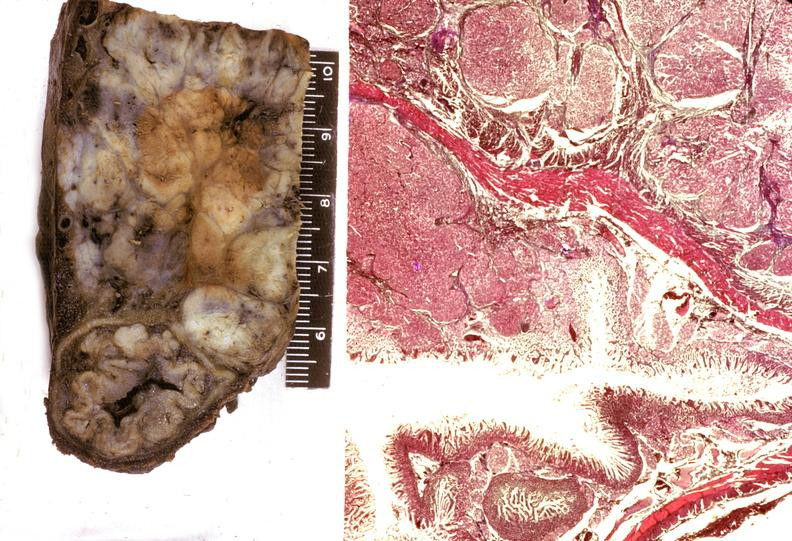s ulcerative lesions slide present?
Answer the question using a single word or phrase. No 